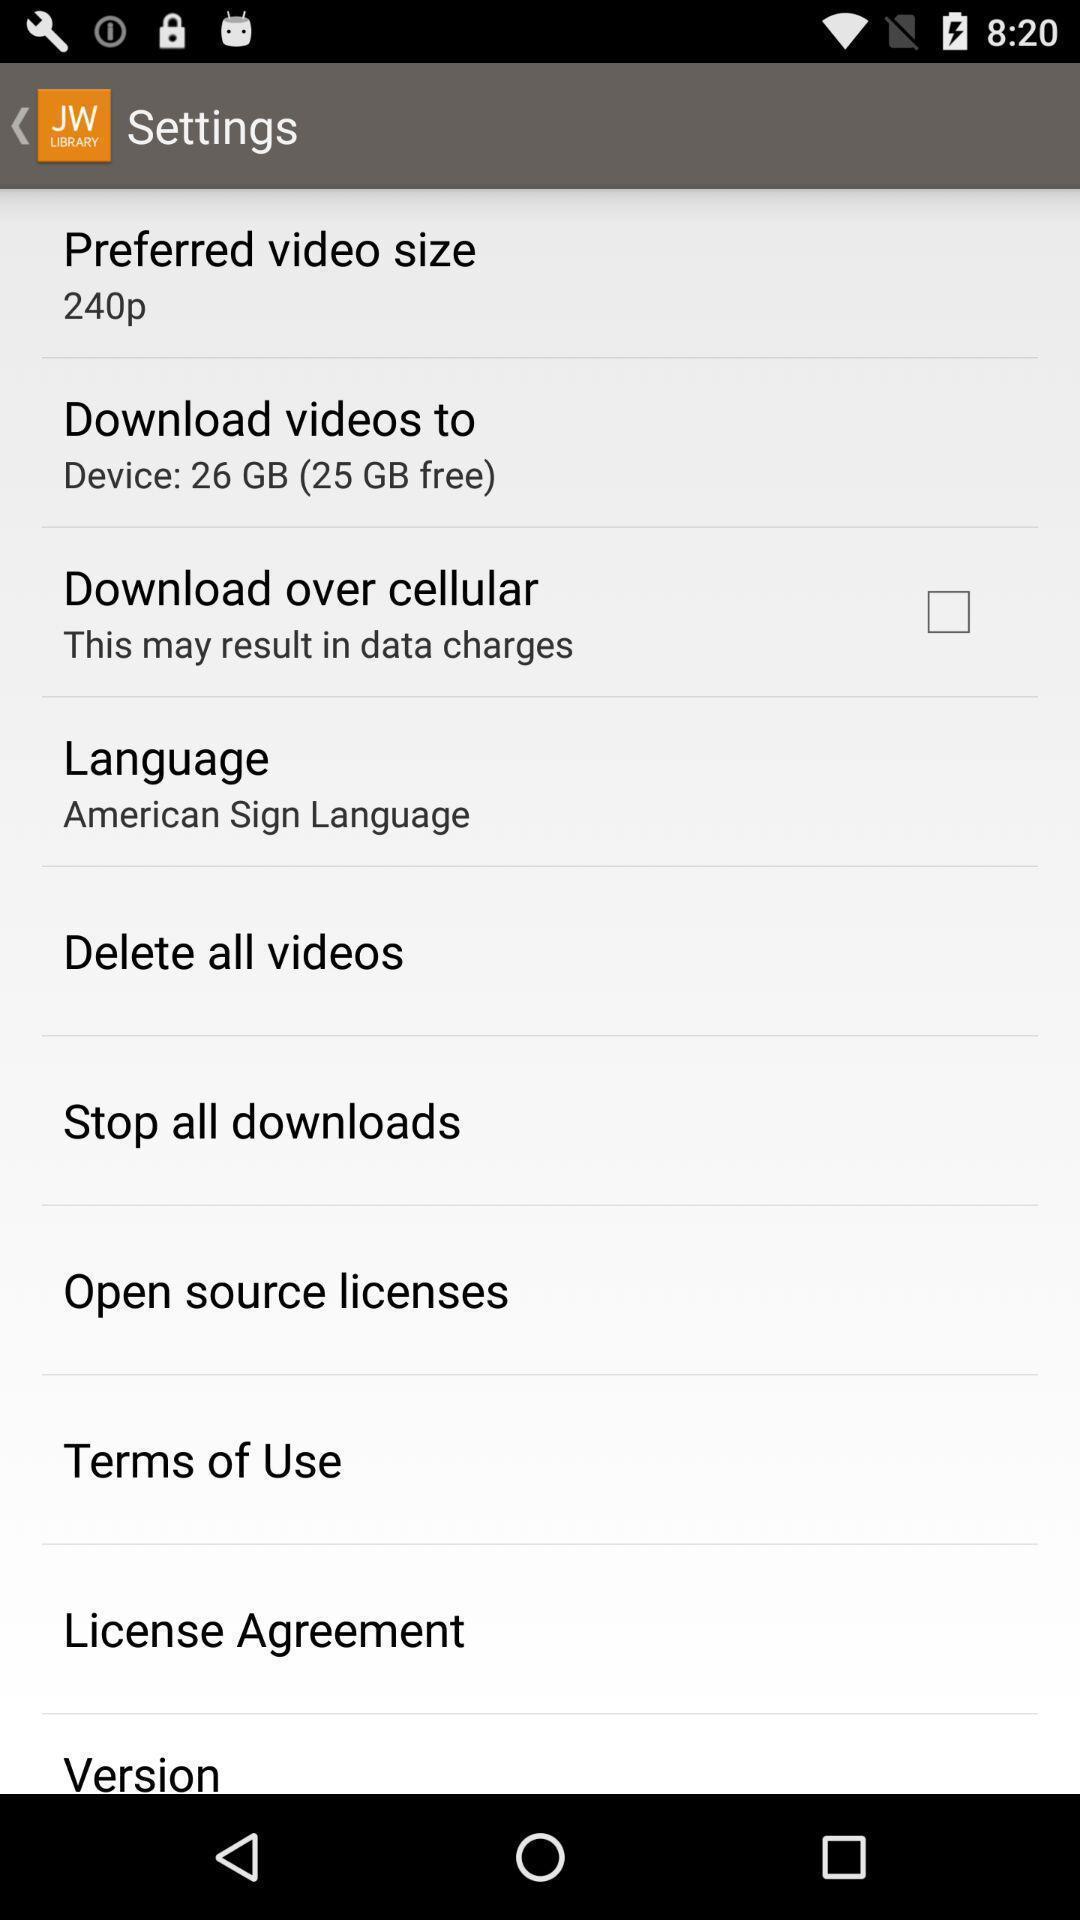What is the overall content of this screenshot? Settings page of sign language app. 